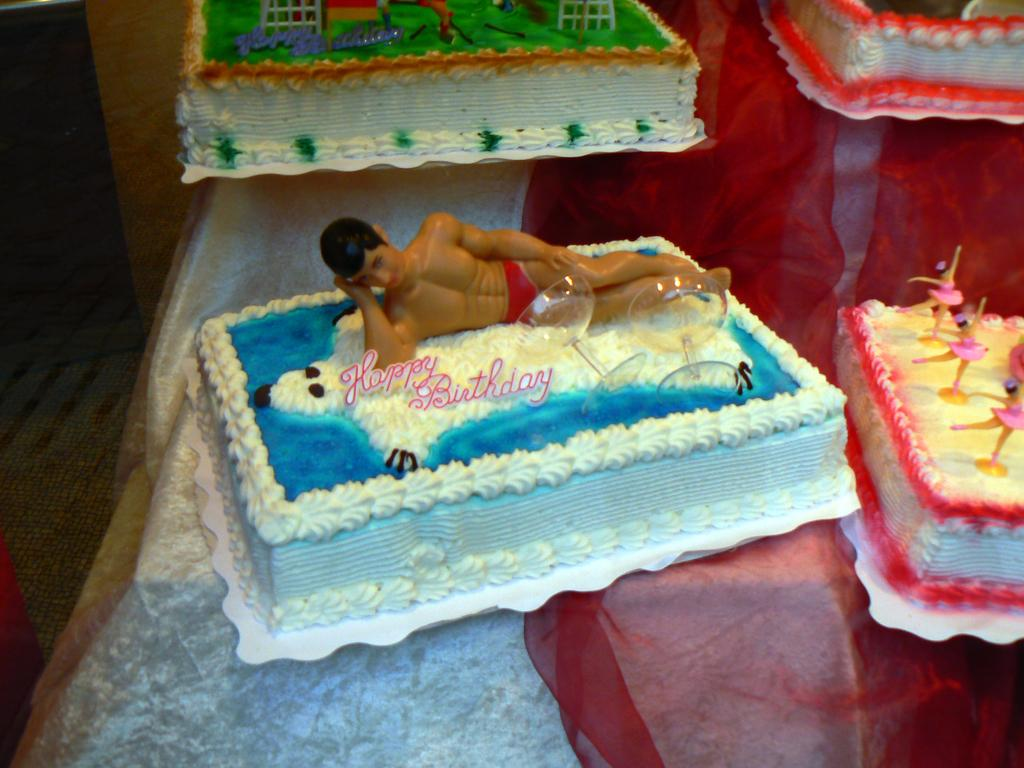What type of food is present on the table in the image? There are cakes on the table in the image. How many cakes can be seen on the table? The number of cakes on the table is not specified in the provided facts. What might be used to serve or cut the cakes in the image? The provided facts do not mention any utensils or serving tools. What type of list is visible on the table in the image? There is no list present in the image; it only features cakes on the table. How much does the dime on the table contribute to the overall value of the items in the image? There is no mention of a dime or any monetary value in the provided facts. 